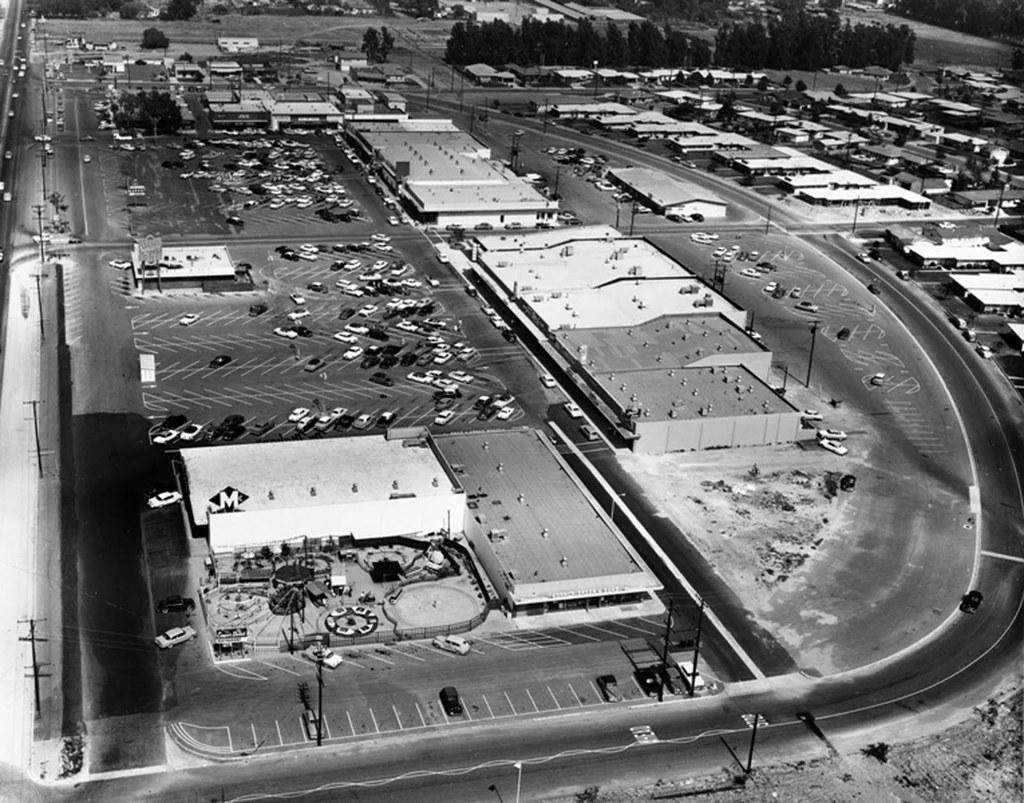What type of vehicles can be seen in the image? There are cars in the image. What structures are present in the image? There are buildings in the image. What type of natural elements can be seen in the image? There are trees in the image. What else is present in the image besides cars, buildings, and trees? There are poles in the image. What is the tendency of the boys to bite in the image? There are no boys present in the image, so it is not possible to determine their tendency to bite. 